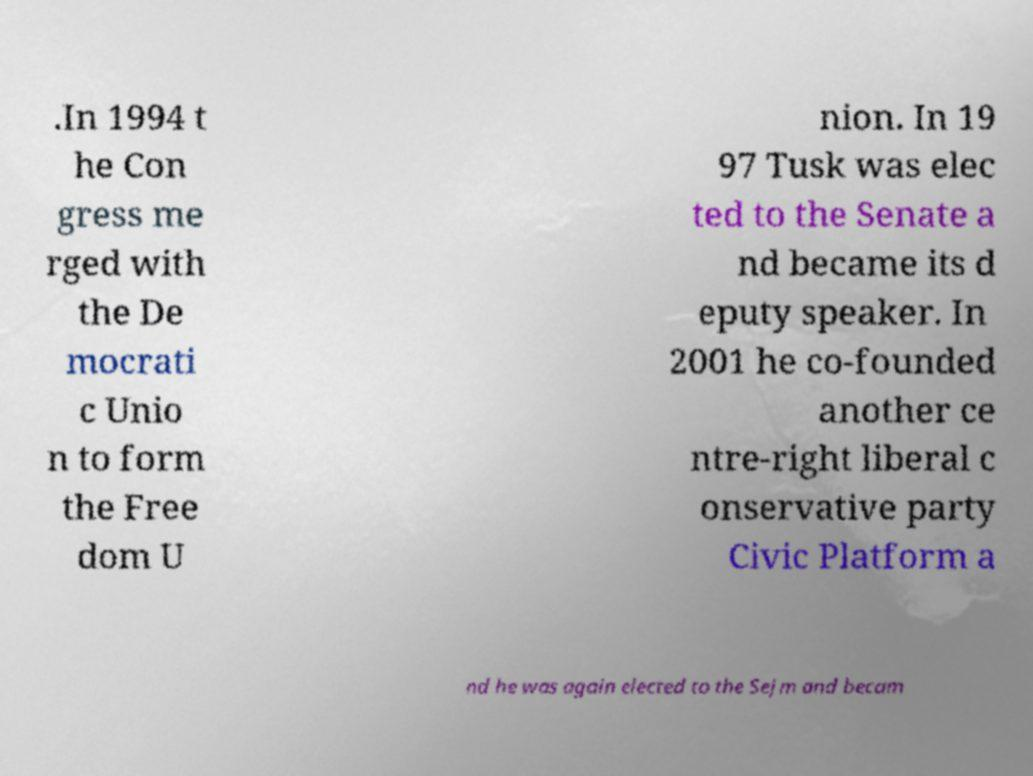Please identify and transcribe the text found in this image. .In 1994 t he Con gress me rged with the De mocrati c Unio n to form the Free dom U nion. In 19 97 Tusk was elec ted to the Senate a nd became its d eputy speaker. In 2001 he co-founded another ce ntre-right liberal c onservative party Civic Platform a nd he was again elected to the Sejm and becam 